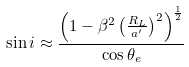Convert formula to latex. <formula><loc_0><loc_0><loc_500><loc_500>\sin i \approx \frac { \left ( 1 - \beta ^ { 2 } \left ( \frac { R _ { L } } { a ^ { \prime } } \right ) ^ { 2 } \right ) ^ { \frac { 1 } { 2 } } } { \cos \theta _ { e } }</formula> 